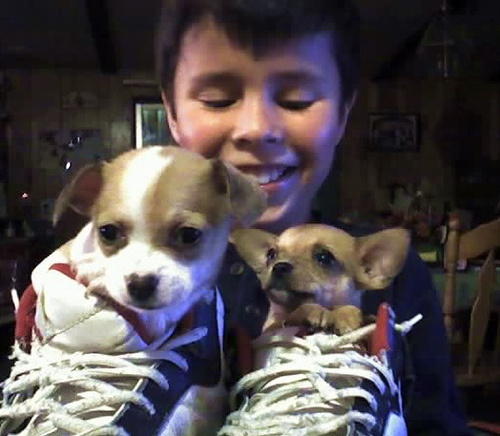Describe the objects in this image and their specific colors. I can see people in black, purple, brown, and navy tones, dog in black, ivory, gray, and tan tones, dog in black, gray, and tan tones, chair in black, maroon, and gray tones, and dining table in black and darkgreen tones in this image. 